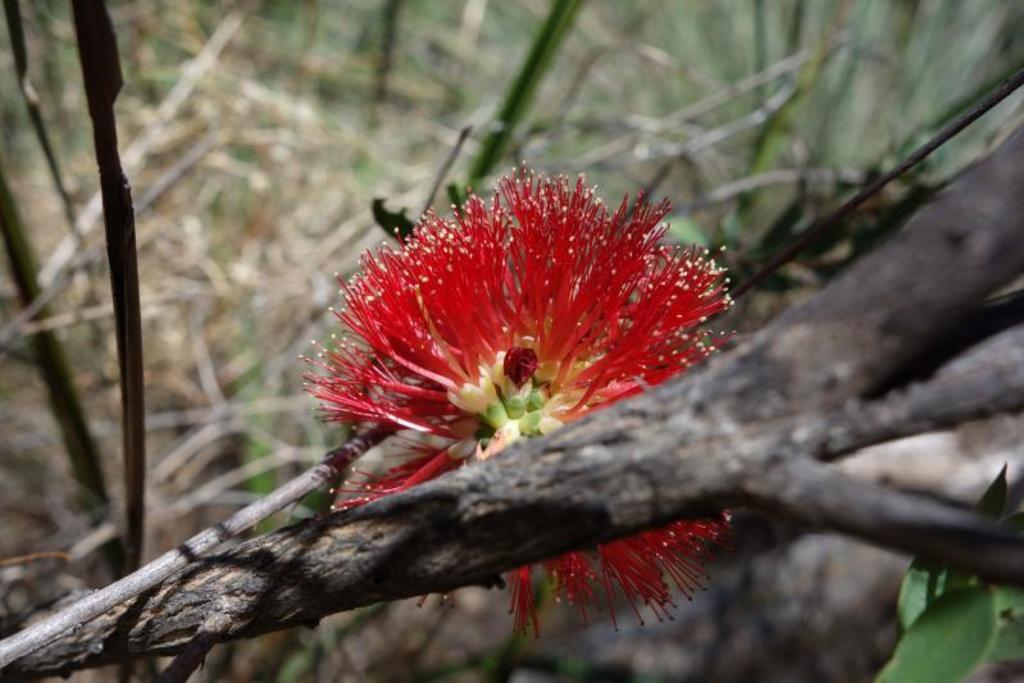What type of flower is in the image? There is a red color flower in the image. Where is the flower located in the image? The flower is in the middle of the image. What other natural elements can be seen in the image? There are trees in the image. What type of industry is depicted in the image? There is no industry depicted in the image; it features a red color flower and trees. Is there a locket hanging from the flower in the image? No, there is no locket present in the image. 